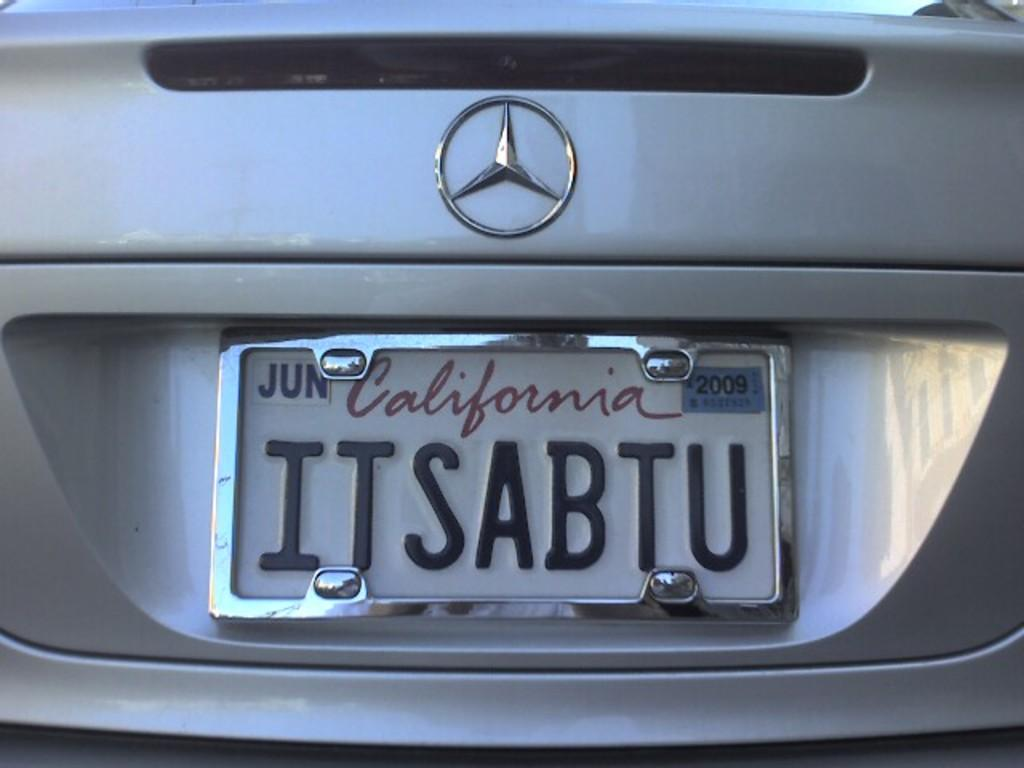<image>
Create a compact narrative representing the image presented. the name California is on the back of a license plate 